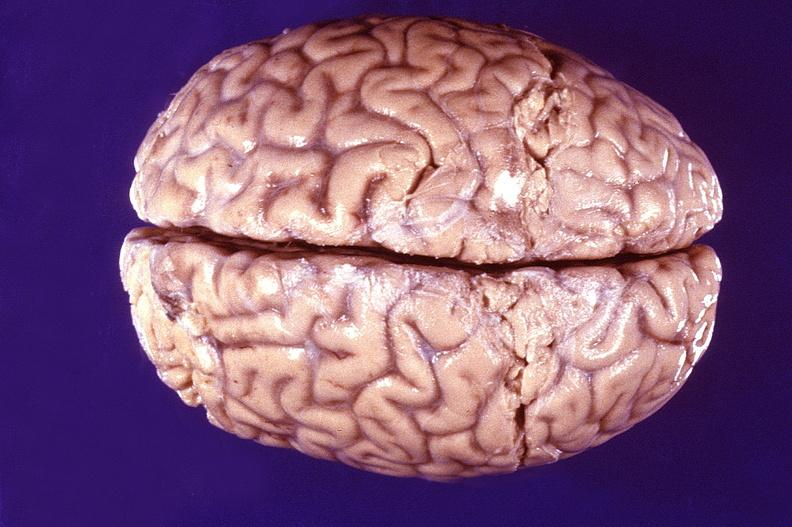s brain present?
Answer the question using a single word or phrase. No 